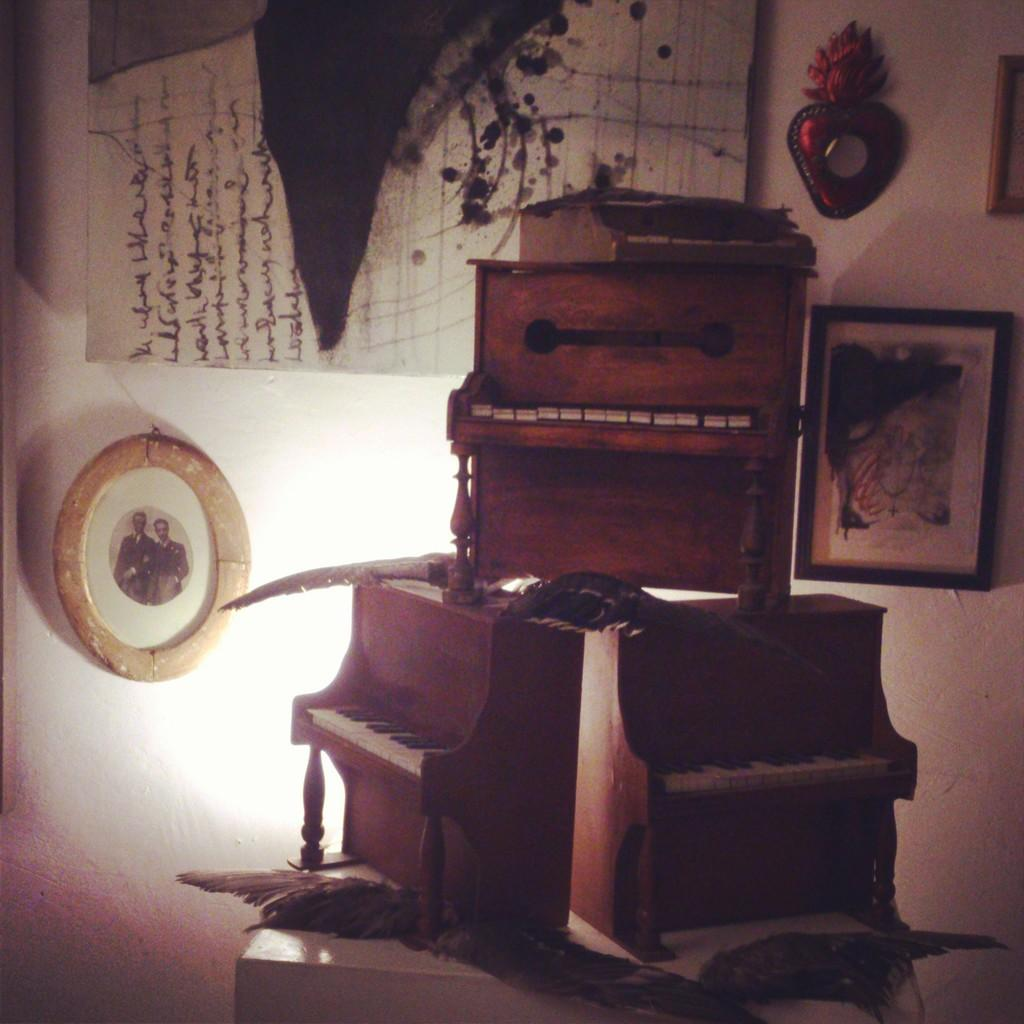What is located in the center of the image? There is a table in the center of the image. What objects are on the table? There are three keyboards on the table. What can be seen in the background of the image? There is a chart, photo frames, a light, and a wall in the background of the image. What type of cakes are being rewarded with rings in the image? There are no cakes or rings present in the image. 